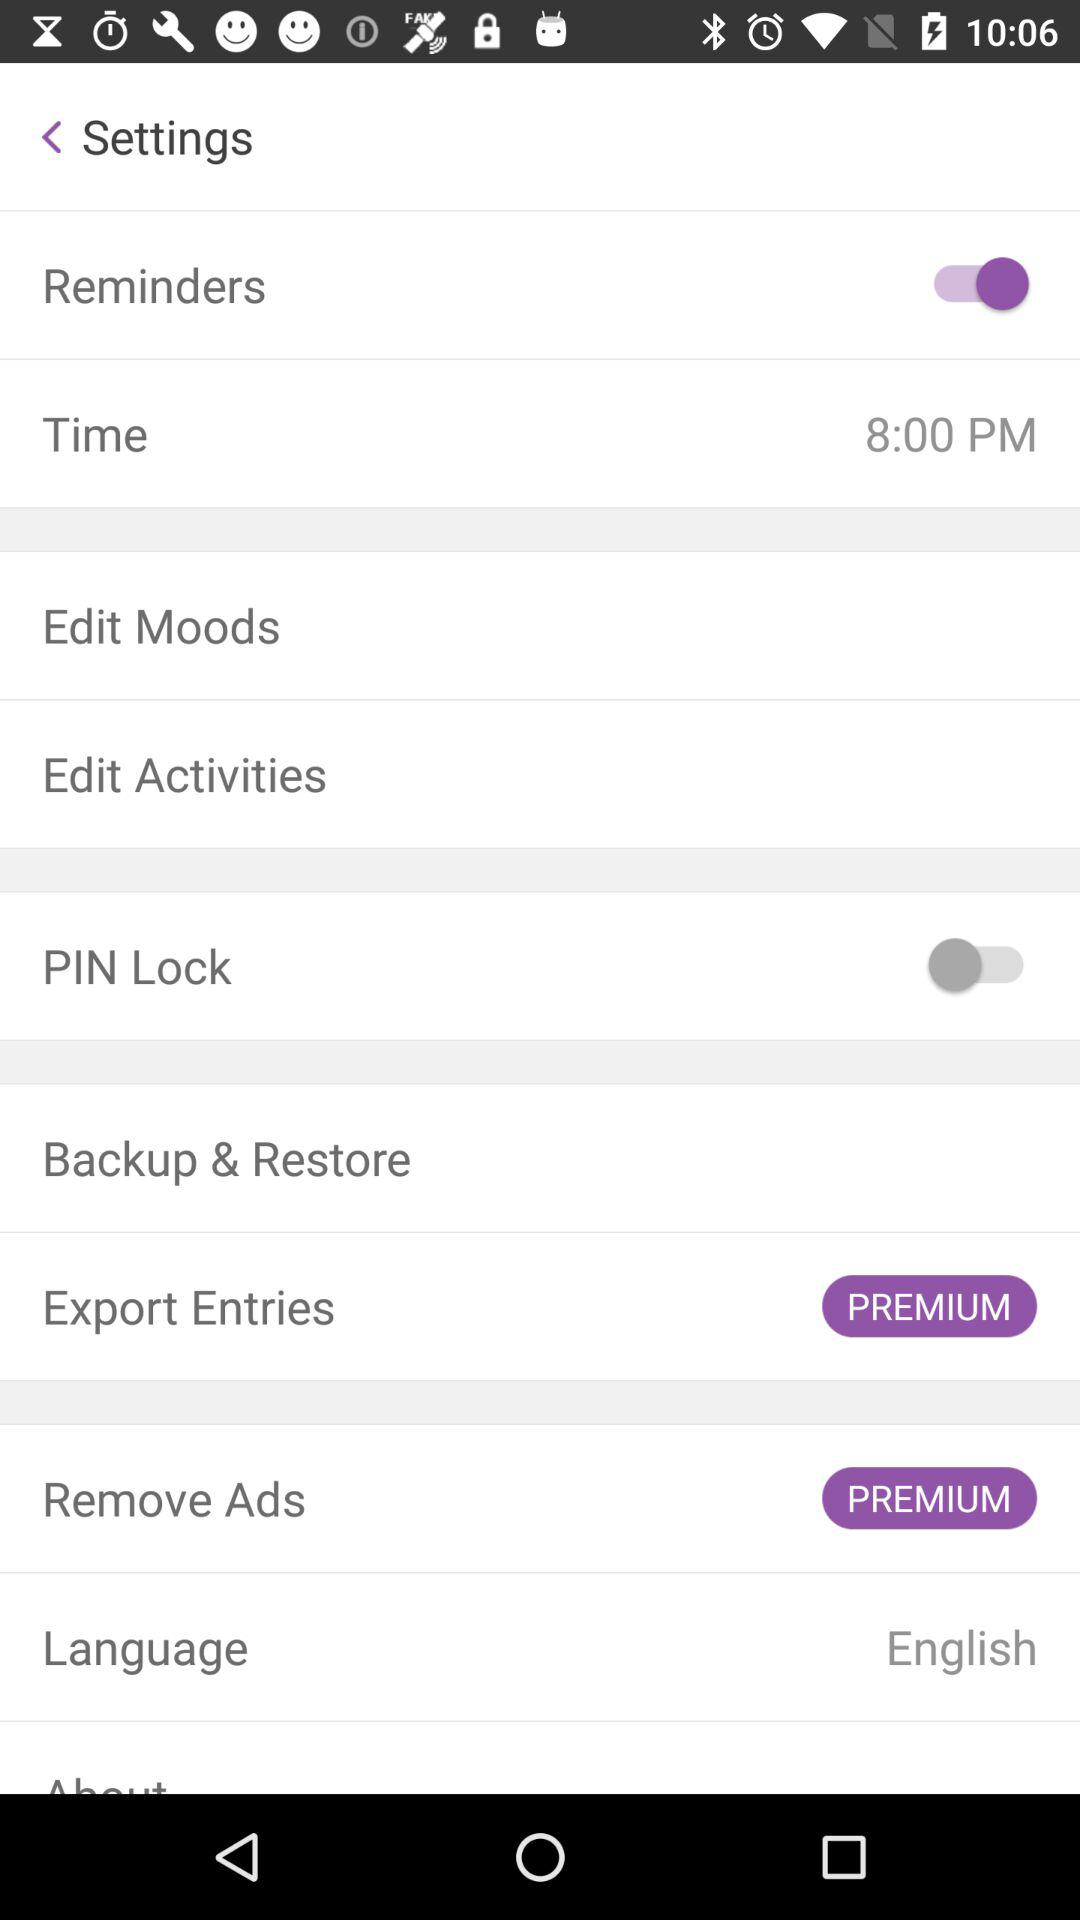What is the status of "Reminders"? The status of "Reminders" is "on". 